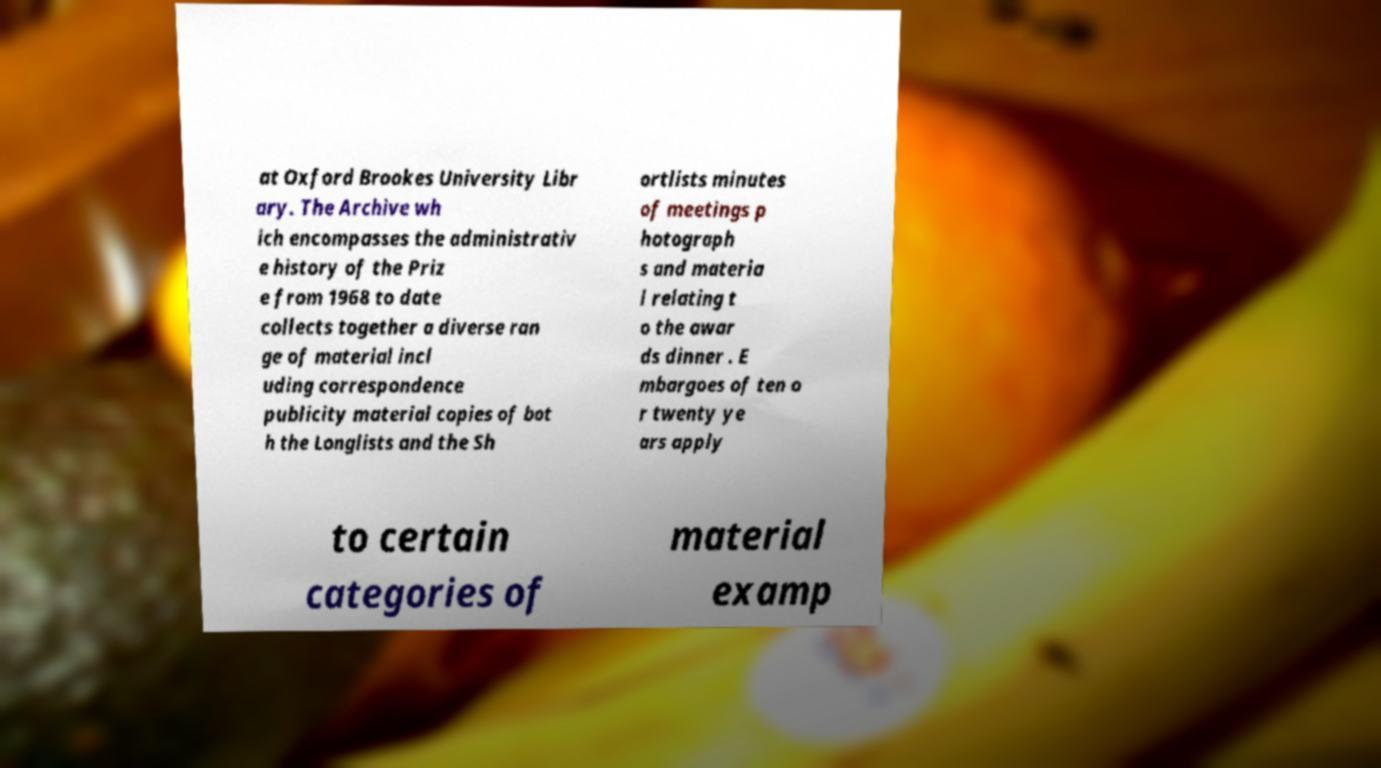What messages or text are displayed in this image? I need them in a readable, typed format. at Oxford Brookes University Libr ary. The Archive wh ich encompasses the administrativ e history of the Priz e from 1968 to date collects together a diverse ran ge of material incl uding correspondence publicity material copies of bot h the Longlists and the Sh ortlists minutes of meetings p hotograph s and materia l relating t o the awar ds dinner . E mbargoes of ten o r twenty ye ars apply to certain categories of material examp 